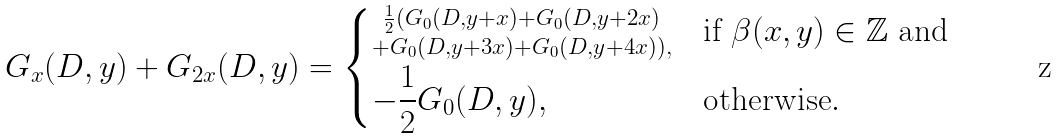<formula> <loc_0><loc_0><loc_500><loc_500>G _ { x } ( D , y ) + G _ { 2 x } ( D , y ) = \begin{dcases} \substack { \frac { 1 } { 2 } ( G _ { 0 } ( D , y + x ) + G _ { 0 } ( D , y + 2 x ) \\ + G _ { 0 } ( D , y + 3 x ) + G _ { 0 } ( D , y + 4 x ) ) , } & \text {if } \beta ( x , y ) \in \mathbb { Z } \text { and } \\ - \frac { 1 } { 2 } G _ { 0 } ( D , y ) , & \text {otherwise} . \end{dcases}</formula> 